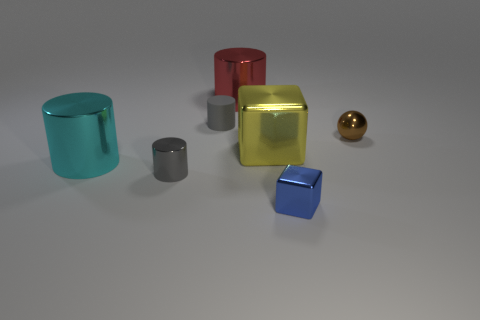What number of other matte objects have the same shape as the tiny rubber object?
Your answer should be very brief. 0. Is the color of the tiny rubber cylinder the same as the tiny cube?
Give a very brief answer. No. Are there fewer shiny cylinders than small gray spheres?
Give a very brief answer. No. What is the material of the gray cylinder in front of the matte cylinder?
Your answer should be very brief. Metal. There is a cyan thing that is the same size as the red metal thing; what is its material?
Make the answer very short. Metal. The big cyan thing that is behind the cylinder that is in front of the big cylinder that is on the left side of the big red cylinder is made of what material?
Your answer should be very brief. Metal. Is the size of the shiny block behind the blue metal cube the same as the cyan metal cylinder?
Offer a very short reply. Yes. Are there more big gray balls than cubes?
Offer a very short reply. No. How many big things are shiny cylinders or brown objects?
Your answer should be compact. 2. How many other things are there of the same color as the small matte thing?
Give a very brief answer. 1. 